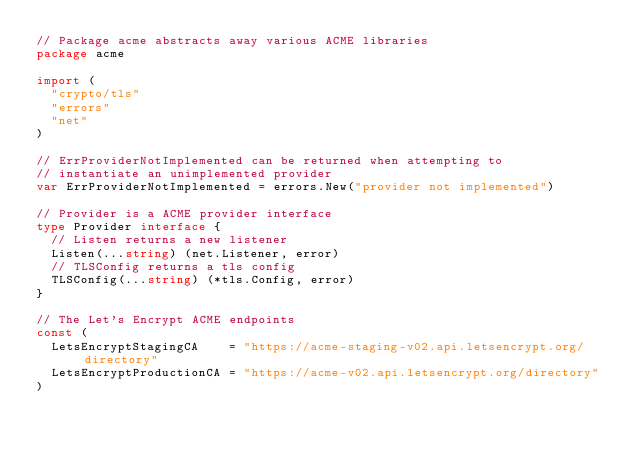Convert code to text. <code><loc_0><loc_0><loc_500><loc_500><_Go_>// Package acme abstracts away various ACME libraries
package acme

import (
	"crypto/tls"
	"errors"
	"net"
)

// ErrProviderNotImplemented can be returned when attempting to
// instantiate an unimplemented provider
var ErrProviderNotImplemented = errors.New("provider not implemented")

// Provider is a ACME provider interface
type Provider interface {
	// Listen returns a new listener
	Listen(...string) (net.Listener, error)
	// TLSConfig returns a tls config
	TLSConfig(...string) (*tls.Config, error)
}

// The Let's Encrypt ACME endpoints
const (
	LetsEncryptStagingCA    = "https://acme-staging-v02.api.letsencrypt.org/directory"
	LetsEncryptProductionCA = "https://acme-v02.api.letsencrypt.org/directory"
)
</code> 